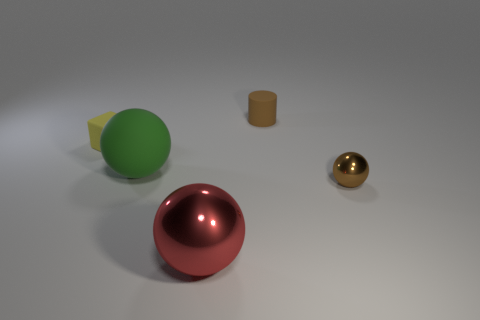Subtract all gray cylinders. Subtract all blue cubes. How many cylinders are left? 1 Add 3 tiny gray cylinders. How many objects exist? 8 Subtract all cylinders. How many objects are left? 4 Subtract 0 green blocks. How many objects are left? 5 Subtract all red metal objects. Subtract all red metallic objects. How many objects are left? 3 Add 3 yellow matte things. How many yellow matte things are left? 4 Add 5 small cyan rubber cylinders. How many small cyan rubber cylinders exist? 5 